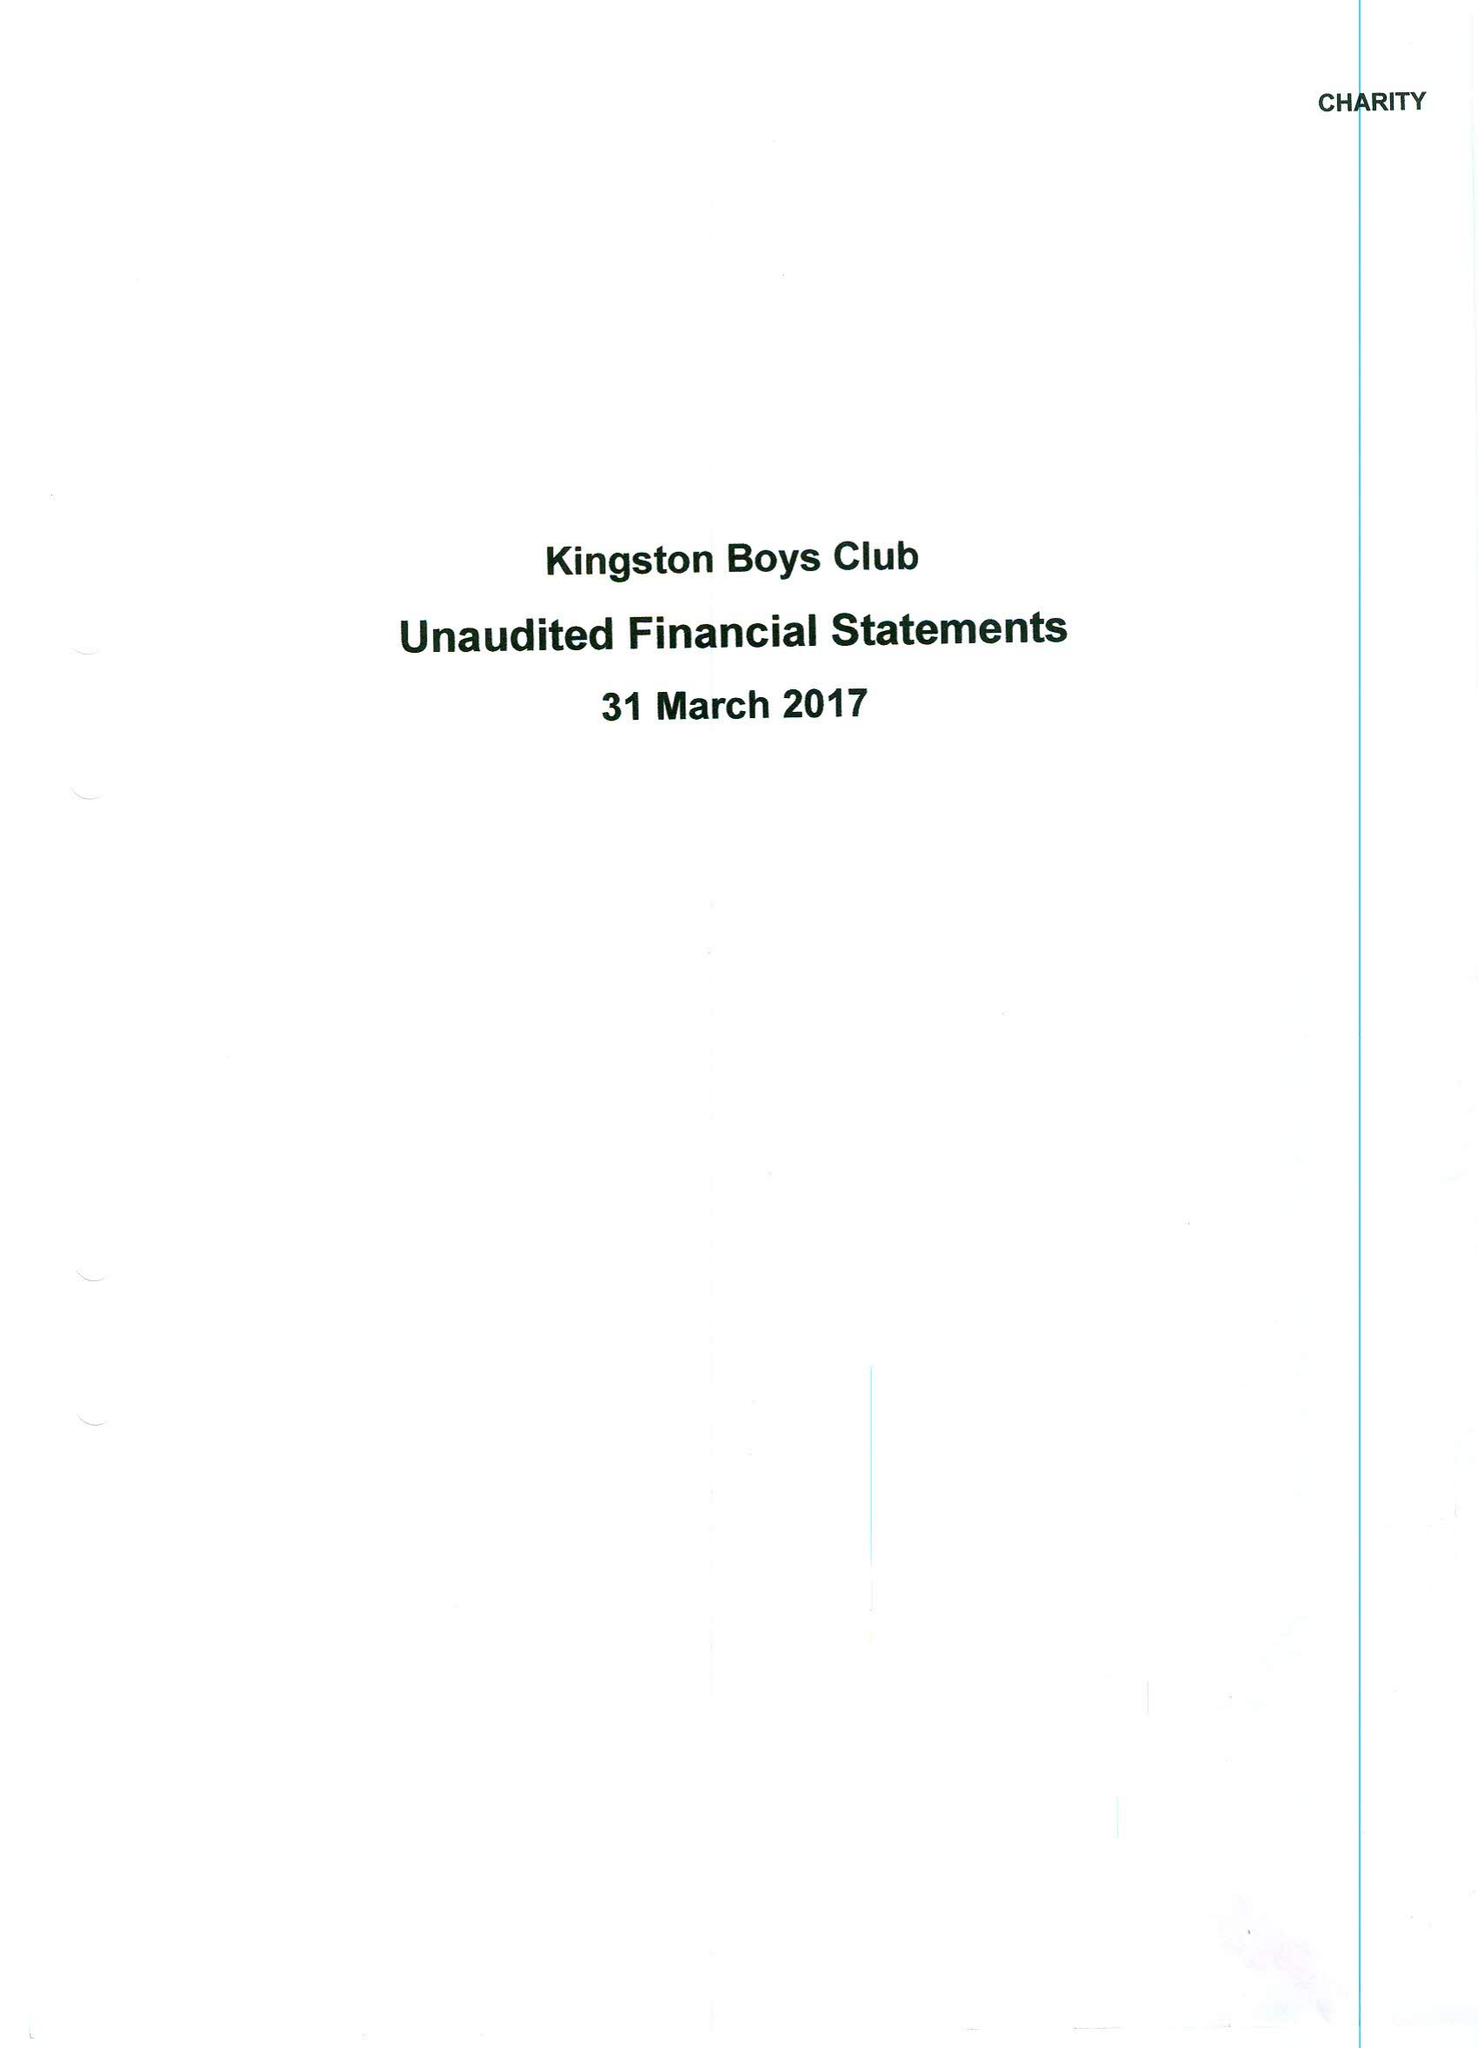What is the value for the charity_number?
Answer the question using a single word or phrase. 303125 